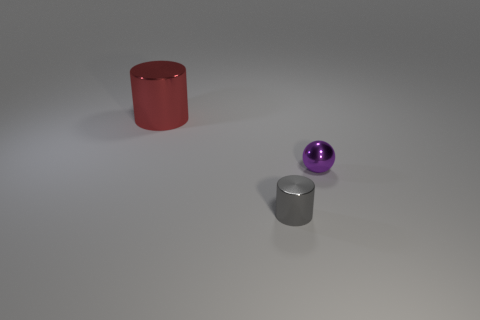The cylinder behind the tiny shiny thing right of the cylinder that is in front of the large red cylinder is what color?
Your response must be concise. Red. Do the large red object and the small purple sphere have the same material?
Keep it short and to the point. Yes. How many purple things are either large shiny objects or tiny spheres?
Your response must be concise. 1. What number of shiny things are in front of the large thing?
Your answer should be very brief. 2. Are there more tiny matte things than small gray things?
Your answer should be very brief. No. The tiny metallic object behind the metallic cylinder in front of the big metal object is what shape?
Keep it short and to the point. Sphere. Does the large metallic cylinder have the same color as the tiny cylinder?
Provide a short and direct response. No. Is the number of small metal objects to the right of the gray object greater than the number of purple spheres?
Offer a terse response. No. How many cylinders are right of the object that is behind the metal sphere?
Make the answer very short. 1. Is the cylinder in front of the big red cylinder made of the same material as the thing that is behind the metal ball?
Ensure brevity in your answer.  Yes. 